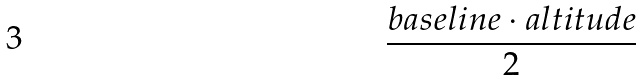Convert formula to latex. <formula><loc_0><loc_0><loc_500><loc_500>\frac { { b a s e l i n e } \cdot { a l t i t u d e } } { 2 }</formula> 